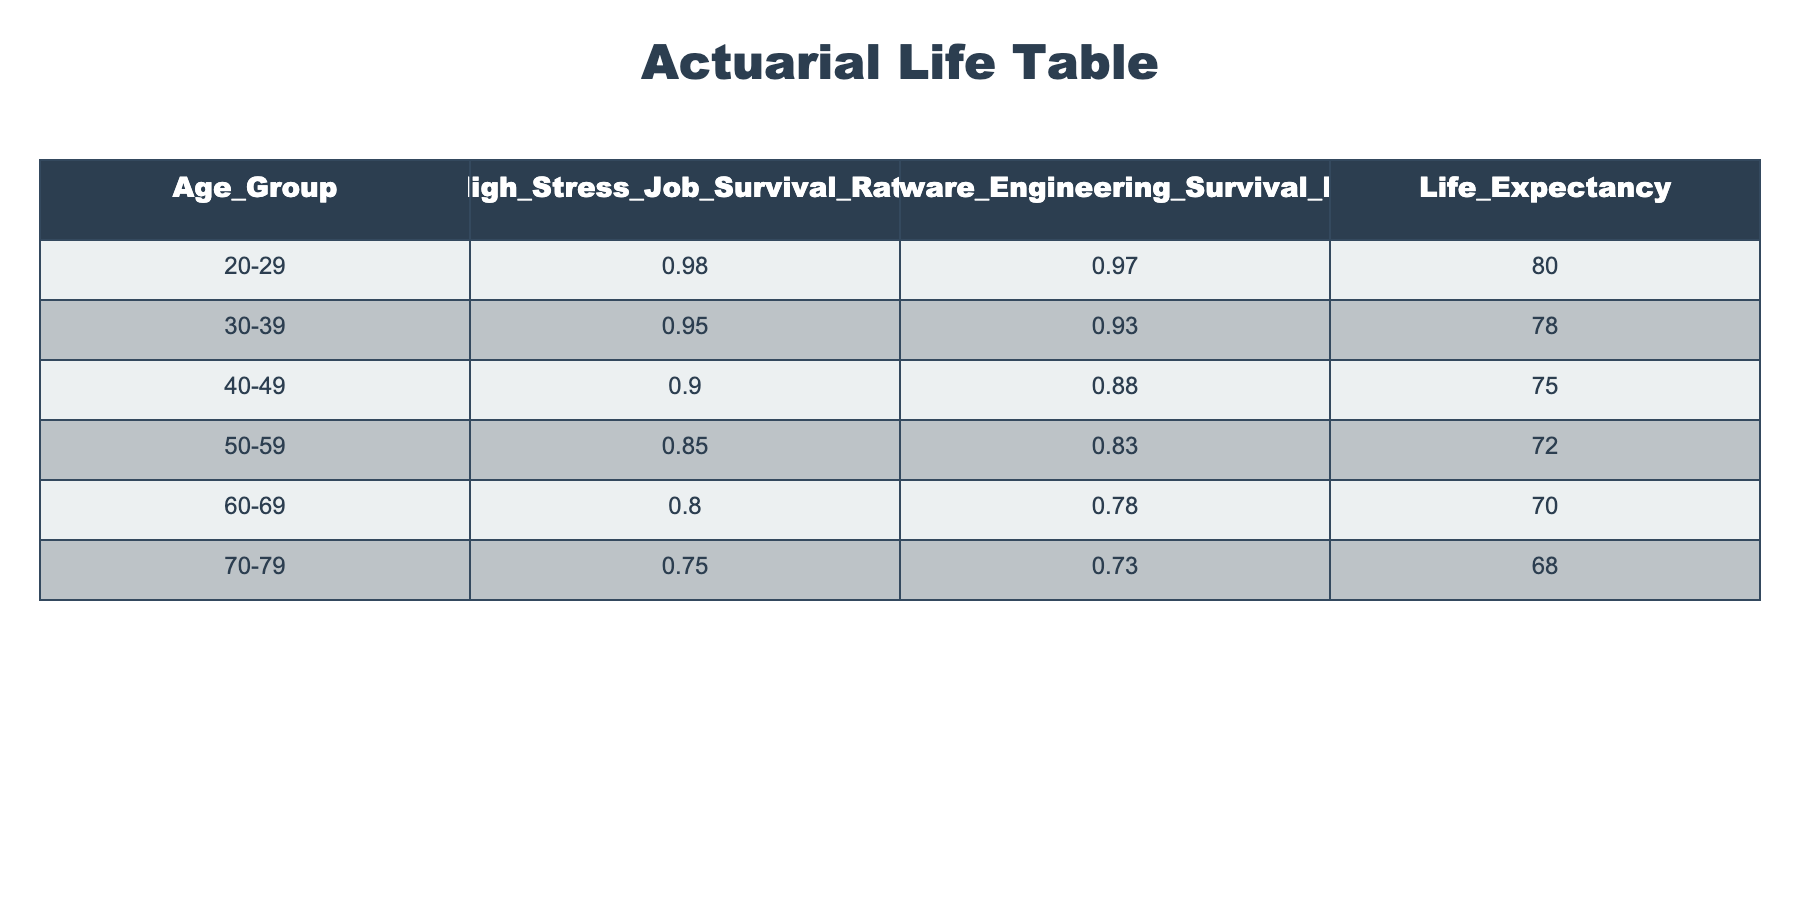What is the survival rate for individuals in high-stress jobs in the age group 30-39? Looking at the table, the "High Stress Job Survival Rate" for the age group 30-39 is listed as 0.95.
Answer: 0.95 What is the difference in survival rates between software engineering and high-stress jobs for individuals aged 40-49? The survival rate for high-stress jobs in the age group 40-49 is 0.90 and for software engineering it is 0.88. The difference is 0.90 - 0.88 = 0.02.
Answer: 0.02 Is the life expectancy for individuals aged 60-69 greater than 70 years? In the table, the life expectancy for the age group 60-69 is listed as 70 years. Therefore, it is not greater than 70 years.
Answer: No What is the average survival rate for individuals in high-stress jobs across all age groups? To calculate the average, we sum the survival rates: 0.98 + 0.95 + 0.90 + 0.85 + 0.80 + 0.75 = 5.23. There are 6 age groups, so the average is 5.23 / 6 ≈ 0.87.
Answer: 0.87 What is the proportional decline in survival rates for software engineering from the age group 20-29 to 70-79? The survival rate for software engineering in age group 20-29 is 0.97, and for 70-79 it is 0.73. The decline is calculated as (0.97 - 0.73) / 0.97 = 0.247 or about 24.7%.
Answer: 24.7% What is the survival rate for individuals in high-stress jobs across all age groups? The survival rates for high-stress jobs are 0.98, 0.95, 0.90, 0.85, 0.80, and 0.75 for the respective age groups. The overall survival rate is the average of these values, which is (0.98 + 0.95 + 0.90 + 0.85 + 0.80 + 0.75) / 6 ≈ 0.87.
Answer: 0.87 Is the survival rate for high-stress jobs highest in the 50-59 age group compared to the younger age groups? The survival rate for high-stress jobs at 50-59 is 0.85, while it is 0.98 for 20-29 and 0.95 for 30-39. Therefore, it is not higher than those younger age groups.
Answer: No What is the combined survival rate for individuals in high-stress jobs aged 30-39 and 40-49? The survival rates for these age groups are 0.95 and 0.90, respectively. The combined survival rate is simply the average: (0.95 + 0.90) / 2 = 0.925.
Answer: 0.925 